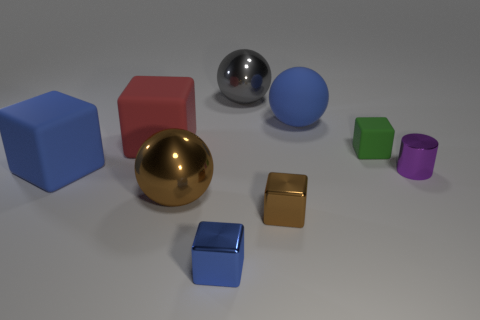Subtract all blue cubes. How many cubes are left? 3 Subtract all brown metal cubes. How many cubes are left? 4 Subtract 1 balls. How many balls are left? 2 Subtract all green blocks. Subtract all blue cylinders. How many blocks are left? 4 Add 1 large red rubber blocks. How many objects exist? 10 Subtract all spheres. How many objects are left? 6 Subtract 0 red spheres. How many objects are left? 9 Subtract all small gray metal spheres. Subtract all small shiny objects. How many objects are left? 6 Add 5 tiny metal cylinders. How many tiny metal cylinders are left? 6 Add 5 tiny shiny blocks. How many tiny shiny blocks exist? 7 